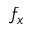<formula> <loc_0><loc_0><loc_500><loc_500>f _ { x }</formula> 